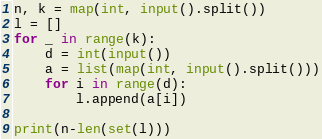Convert code to text. <code><loc_0><loc_0><loc_500><loc_500><_Python_>n, k = map(int, input().split())
l = []
for _ in range(k):
    d = int(input())
    a = list(map(int, input().split()))
    for i in range(d):
        l.append(a[i])

print(n-len(set(l)))
</code> 